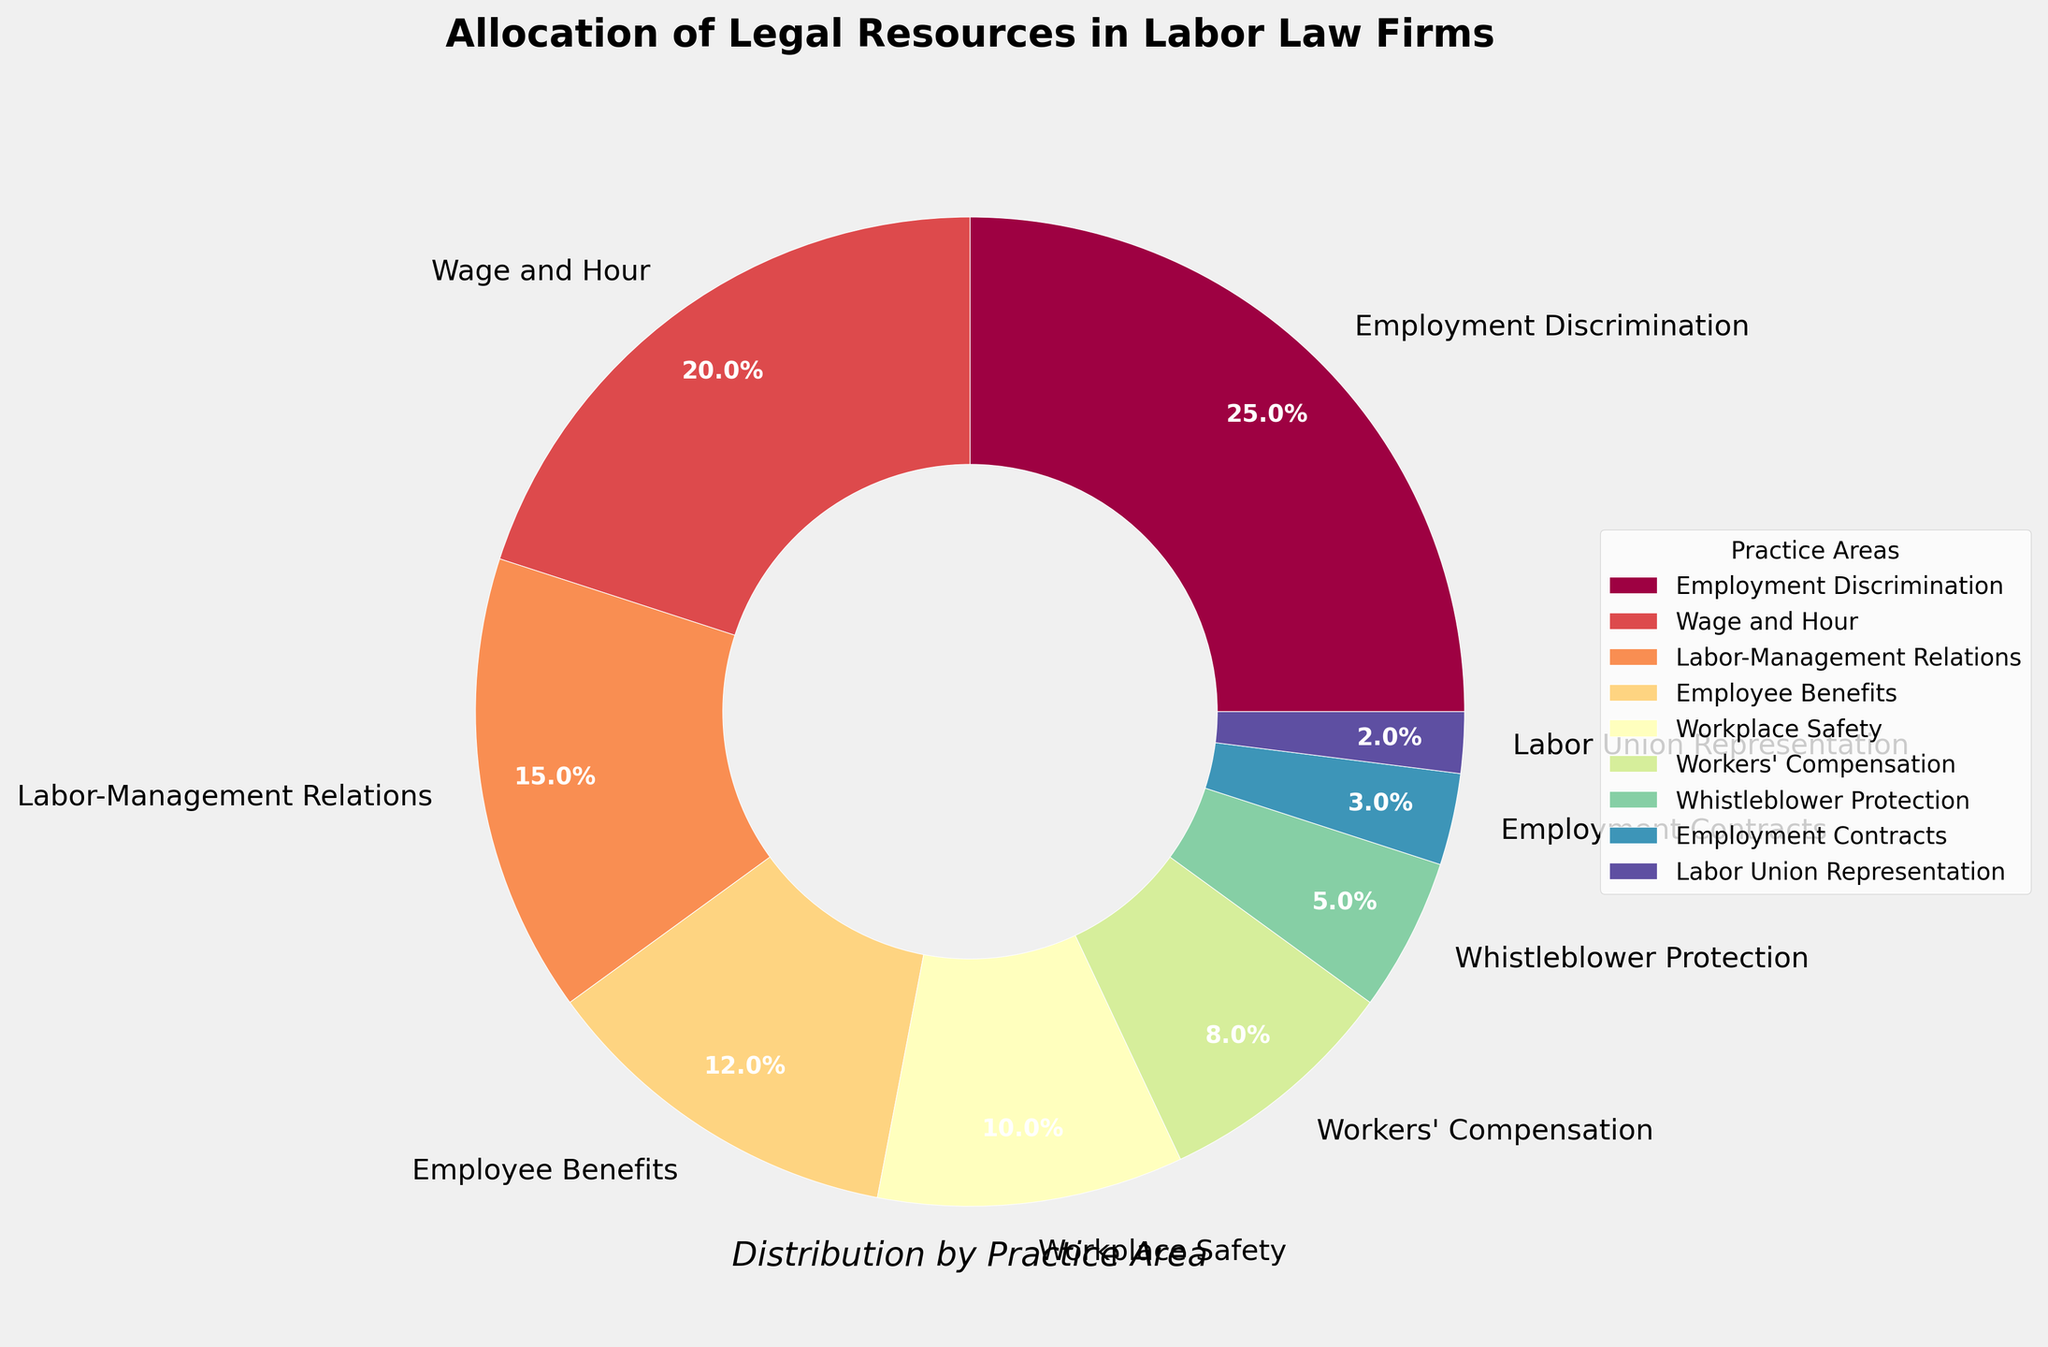What percentage of legal resources are allocated to Workplace Safety and Workers' Compensation combined? Add the percentages of Workplace Safety and Workers' Compensation from the chart: 10% (Workplace Safety) + 8% (Workers' Compensation) = 18%
Answer: 18% Which has a higher allocation of legal resources: Wage and Hour or Labor-Management Relations? Compare the percentages of Wage and Hour (20%) and Labor-Management Relations (15%). Wage and Hour has a higher allocation.
Answer: Wage and Hour What is the least allocated practice area in the chart? Identify the smallest percentage in the chart, which is Labor Union Representation at 2%.
Answer: Labor Union Representation How much more legal resources are allocated to Employment Discrimination than Whistleblower Protection? Subtract the percentage of Whistleblower Protection (5%) from the percentage of Employment Discrimination (25%): 25% - 5% = 20%
Answer: 20% What fraction of the total legal resources is allocated to Employee Benefits and Employment Contracts combined? Add the percentages of Employee Benefits (12%) and Employment Contracts (3%): 12% + 3% = 15%. Then, express 15% as a fraction of the total 100%, which is 15/100 or 3/20.
Answer: 3/20 Does the combined allocation for Employment Contracts and Labor Union Representation exceed that of Whistleblower Protection? Add the percentages of Employment Contracts (3%) and Labor Union Representation (2%): 3% + 2% = 5%. Compare this with Whistleblower Protection's 5%, which shows they are equal.
Answer: No Which practice areas have allocations of legal resources above 10%? Identify all practice areas with percentages greater than 10%: Employment Discrimination (25%), Wage and Hour (20%), Labor-Management Relations (15%), Employee Benefits (12%), and Workplace Safety (10%). Since Workplace Safety is exactly 10%, it’s not above 10%.
Answer: Employment Discrimination, Wage and Hour, Labor-Management Relations, Employee Benefits Is the allocation for Workers' Compensation more than half of the allocation for Wage and Hour? Compare half of Wage and Hour's percentage (20% / 2 = 10%) with Workers' Compensation (8%). Since 8% is less than 10%, it's not more than half.
Answer: No What practice area immediately follows Workplace Safety in the allocation of resources? Workplace Safety is allocated 10% of legal resources. Looking at the next largest allocation after Workplace Safety, it is Workers' Compensation with 8%.
Answer: Workers' Compensation 